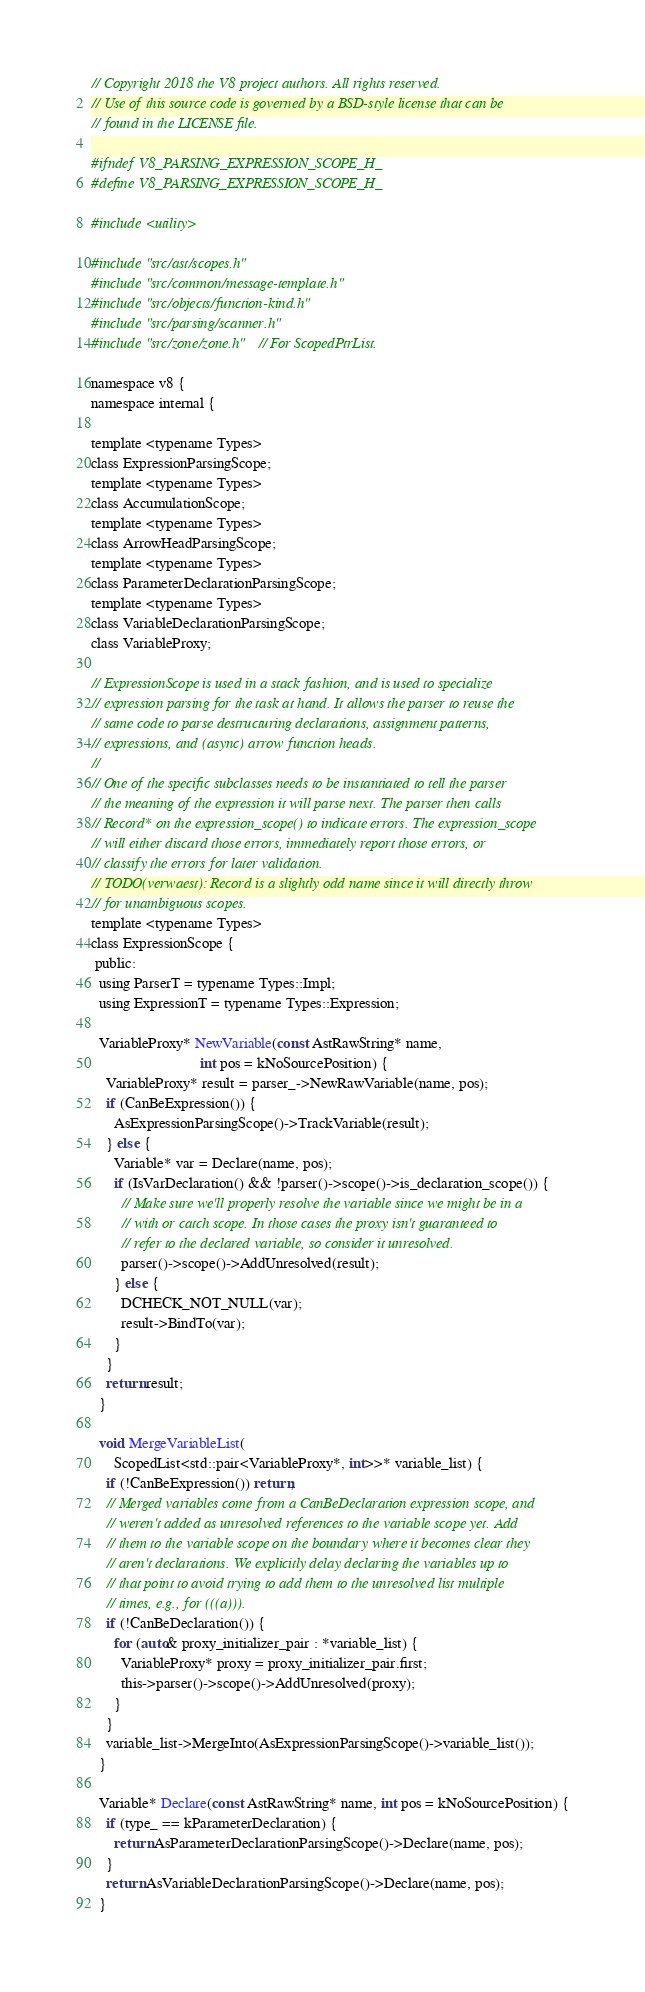<code> <loc_0><loc_0><loc_500><loc_500><_C_>// Copyright 2018 the V8 project authors. All rights reserved.
// Use of this source code is governed by a BSD-style license that can be
// found in the LICENSE file.

#ifndef V8_PARSING_EXPRESSION_SCOPE_H_
#define V8_PARSING_EXPRESSION_SCOPE_H_

#include <utility>

#include "src/ast/scopes.h"
#include "src/common/message-template.h"
#include "src/objects/function-kind.h"
#include "src/parsing/scanner.h"
#include "src/zone/zone.h"  // For ScopedPtrList.

namespace v8 {
namespace internal {

template <typename Types>
class ExpressionParsingScope;
template <typename Types>
class AccumulationScope;
template <typename Types>
class ArrowHeadParsingScope;
template <typename Types>
class ParameterDeclarationParsingScope;
template <typename Types>
class VariableDeclarationParsingScope;
class VariableProxy;

// ExpressionScope is used in a stack fashion, and is used to specialize
// expression parsing for the task at hand. It allows the parser to reuse the
// same code to parse destructuring declarations, assignment patterns,
// expressions, and (async) arrow function heads.
//
// One of the specific subclasses needs to be instantiated to tell the parser
// the meaning of the expression it will parse next. The parser then calls
// Record* on the expression_scope() to indicate errors. The expression_scope
// will either discard those errors, immediately report those errors, or
// classify the errors for later validation.
// TODO(verwaest): Record is a slightly odd name since it will directly throw
// for unambiguous scopes.
template <typename Types>
class ExpressionScope {
 public:
  using ParserT = typename Types::Impl;
  using ExpressionT = typename Types::Expression;

  VariableProxy* NewVariable(const AstRawString* name,
                             int pos = kNoSourcePosition) {
    VariableProxy* result = parser_->NewRawVariable(name, pos);
    if (CanBeExpression()) {
      AsExpressionParsingScope()->TrackVariable(result);
    } else {
      Variable* var = Declare(name, pos);
      if (IsVarDeclaration() && !parser()->scope()->is_declaration_scope()) {
        // Make sure we'll properly resolve the variable since we might be in a
        // with or catch scope. In those cases the proxy isn't guaranteed to
        // refer to the declared variable, so consider it unresolved.
        parser()->scope()->AddUnresolved(result);
      } else {
        DCHECK_NOT_NULL(var);
        result->BindTo(var);
      }
    }
    return result;
  }

  void MergeVariableList(
      ScopedList<std::pair<VariableProxy*, int>>* variable_list) {
    if (!CanBeExpression()) return;
    // Merged variables come from a CanBeDeclaration expression scope, and
    // weren't added as unresolved references to the variable scope yet. Add
    // them to the variable scope on the boundary where it becomes clear they
    // aren't declarations. We explicitly delay declaring the variables up to
    // that point to avoid trying to add them to the unresolved list multiple
    // times, e.g., for (((a))).
    if (!CanBeDeclaration()) {
      for (auto& proxy_initializer_pair : *variable_list) {
        VariableProxy* proxy = proxy_initializer_pair.first;
        this->parser()->scope()->AddUnresolved(proxy);
      }
    }
    variable_list->MergeInto(AsExpressionParsingScope()->variable_list());
  }

  Variable* Declare(const AstRawString* name, int pos = kNoSourcePosition) {
    if (type_ == kParameterDeclaration) {
      return AsParameterDeclarationParsingScope()->Declare(name, pos);
    }
    return AsVariableDeclarationParsingScope()->Declare(name, pos);
  }
</code> 